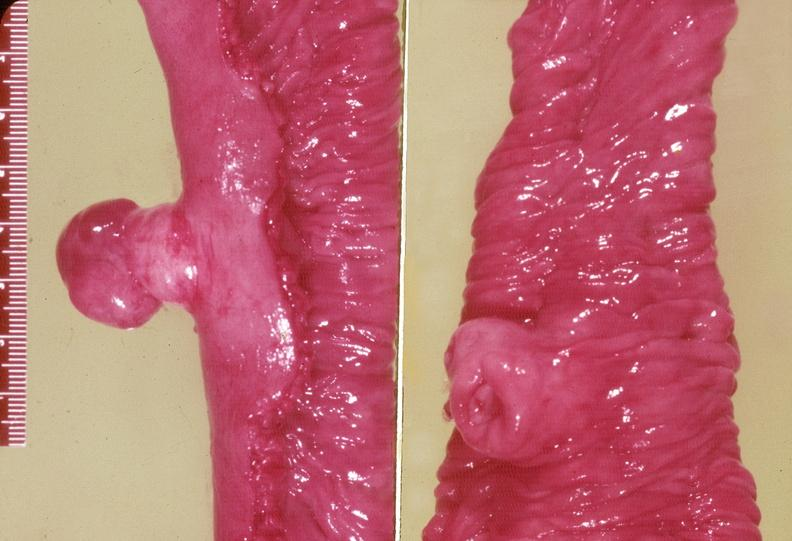s gastrointestinal present?
Answer the question using a single word or phrase. Yes 